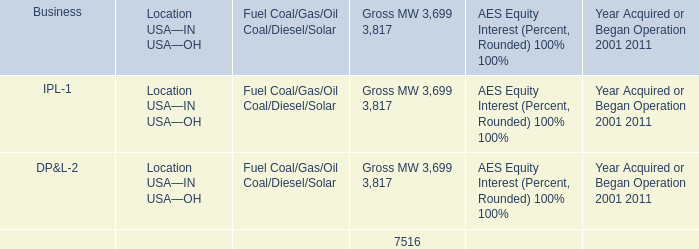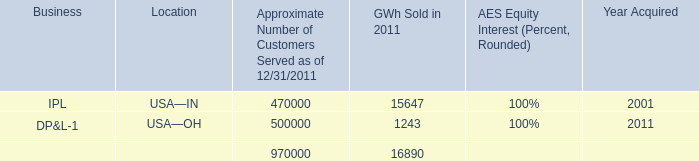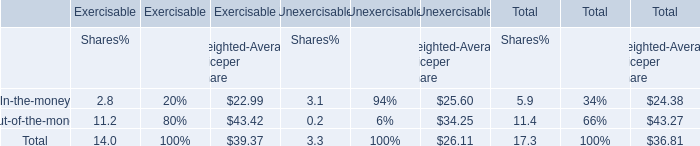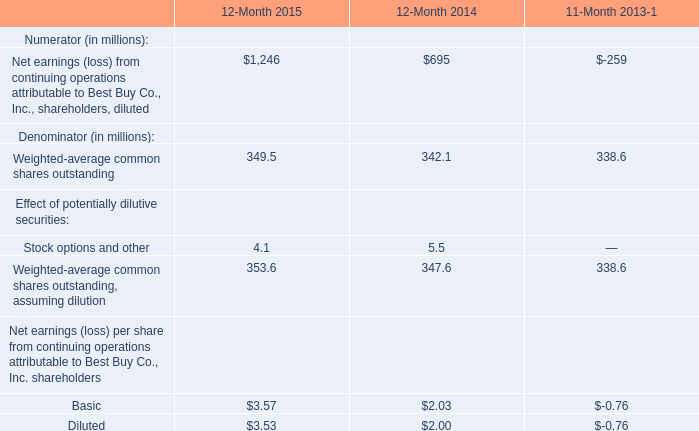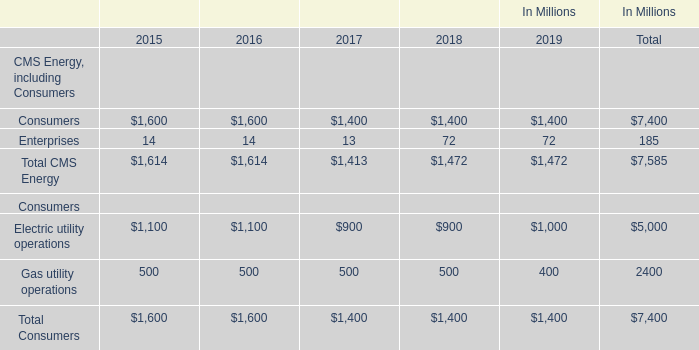In the year with lowest of Total CMS Energy, what's the increasing rate of Total Consumers? 
Computations: ((1400 - 1600) / 1600)
Answer: -0.125. 